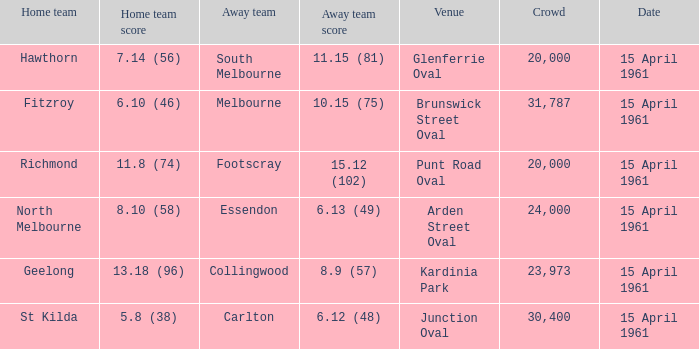What is the average crowd size when Collingwood is the away team? 23973.0. 